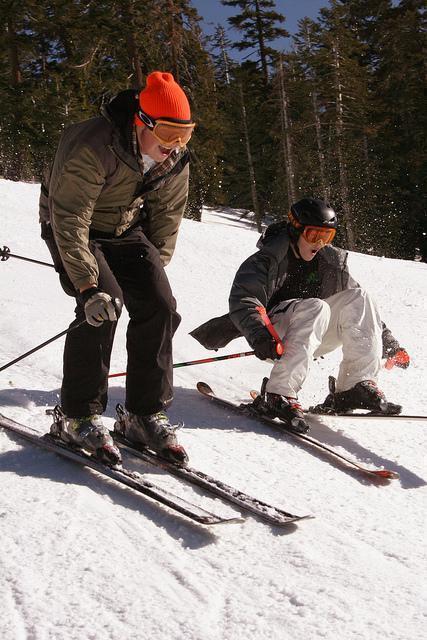What is this sport name?
Indicate the correct choice and explain in the format: 'Answer: answer
Rationale: rationale.'
Options: Skating, surfing, skiing, swimming. Answer: skiing.
Rationale: As indicated by the skis on their feet. 